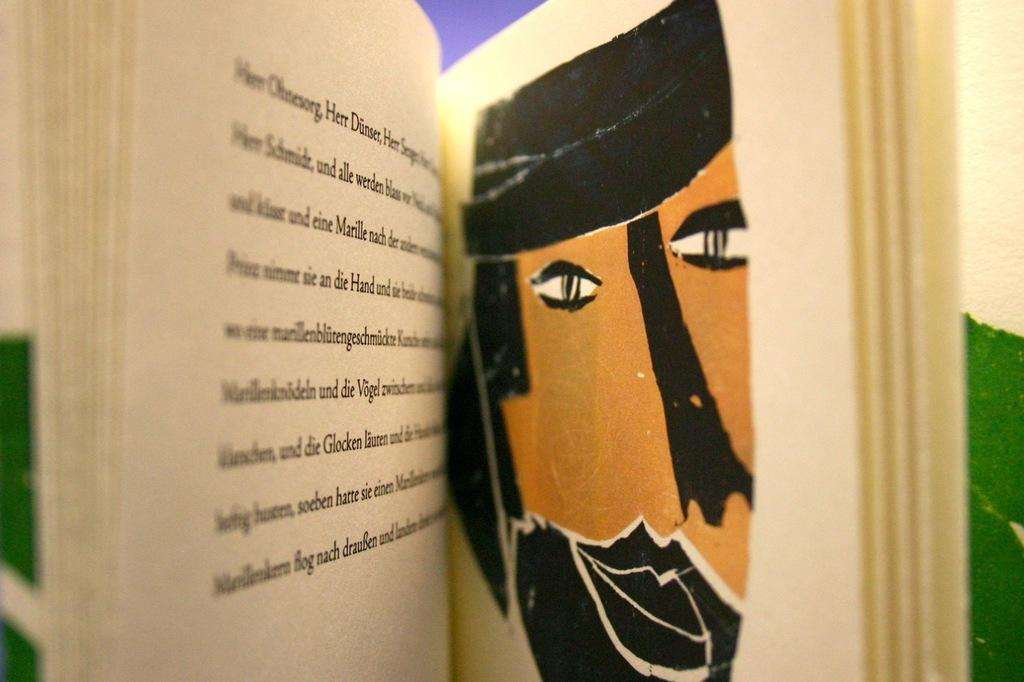What is the main object in the image? There is a book in the image. What can be found inside the book? The book contains a drawing of a person. Is there any text associated with the drawing? Yes, there is text written on the drawing. What type of carpenter is depicted in the waves on the page? There is no carpenter or waves present in the image; it features a book with a drawing of a person and text. 